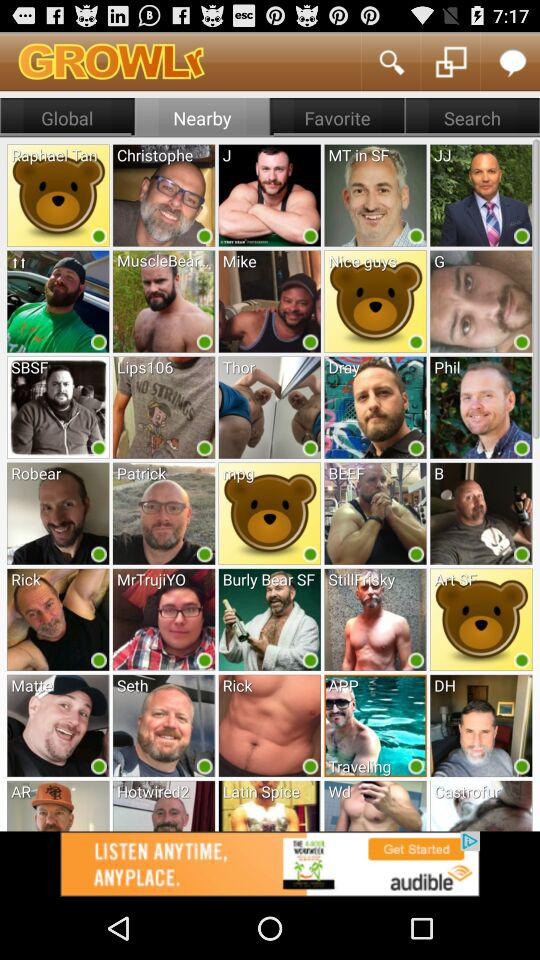What is the name of the application? The name of the application is "GROWLr". 